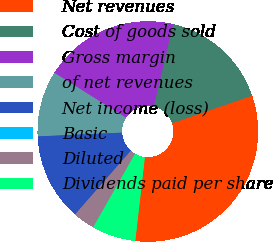Convert chart to OTSL. <chart><loc_0><loc_0><loc_500><loc_500><pie_chart><fcel>Net revenues<fcel>Cost of goods sold<fcel>Gross margin<fcel>of net revenues<fcel>Net income (loss)<fcel>Basic<fcel>Diluted<fcel>Dividends paid per share<nl><fcel>32.09%<fcel>16.05%<fcel>19.77%<fcel>9.63%<fcel>12.84%<fcel>0.0%<fcel>3.21%<fcel>6.42%<nl></chart> 